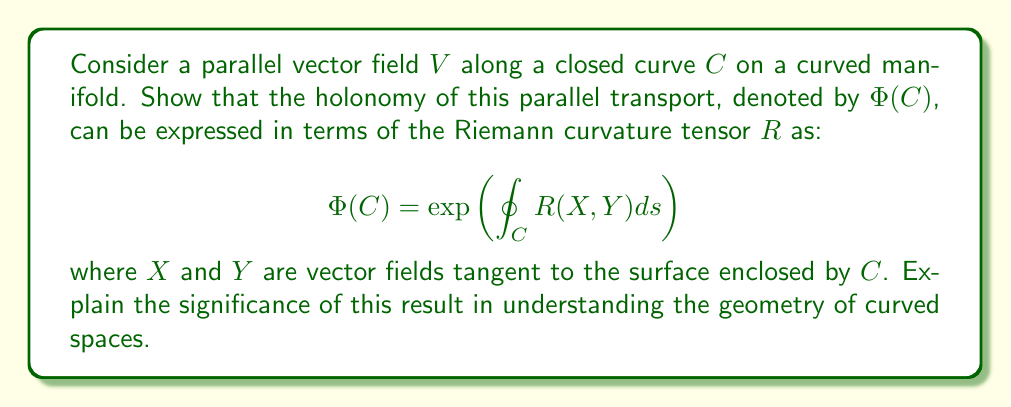Give your solution to this math problem. 1) First, recall that parallel transport preserves the length and angle of vectors as they move along a curve. In flat space, a vector parallel transported around a closed loop returns to its original orientation. However, in curved space, this is not generally true.

2) The holonomy $\Phi(C)$ quantifies how much a vector changes after being parallel transported around a closed curve $C$. It can be thought of as a rotation in the tangent space.

3) The Riemann curvature tensor $R$ measures the local curvature of a manifold. For vector fields $X$, $Y$, $Z$, and $W$, it is defined as:

   $$R(X,Y)Z = \nabla_X\nabla_Y Z - \nabla_Y\nabla_X Z - \nabla_{[X,Y]}Z$$

   where $\nabla$ is the covariant derivative and $[X,Y]$ is the Lie bracket.

4) The relation between holonomy and curvature is given by the holonomy theorem, which states that for a small loop:

   $$\Phi(C) \approx I + \int_S R(X,Y)dA$$

   where $S$ is the surface enclosed by $C$, and $dA$ is the area element.

5) For a finite loop, this becomes an exponential:

   $$\Phi(C) = \exp\left(\oint_C R(X, Y)ds\right)$$

6) This formula shows that the holonomy of parallel transport around a closed curve is determined by the integral of the Riemann curvature tensor over the enclosed surface.

7) The significance of this result is profound:
   - It directly relates the global property of parallel transport to the local property of curvature.
   - It shows that non-zero curvature leads to non-trivial holonomy, i.e., vectors change when parallel transported around closed loops.
   - It provides a way to "measure" curvature by observing how vectors change under parallel transport.

8) This relationship is crucial in understanding the geometry of curved spaces, as it connects the abstract notion of curvature to the more intuitive concept of how vectors behave when moved around on the manifold.
Answer: The holonomy of parallel transport is the exponential of the integral of the Riemann curvature tensor over the enclosed surface, linking local curvature to global parallel transport behavior. 